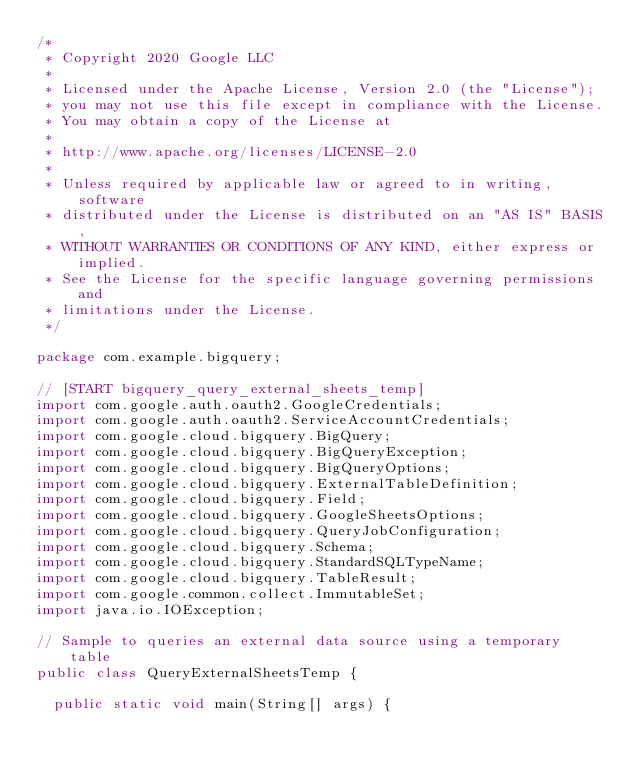<code> <loc_0><loc_0><loc_500><loc_500><_Java_>/*
 * Copyright 2020 Google LLC
 *
 * Licensed under the Apache License, Version 2.0 (the "License");
 * you may not use this file except in compliance with the License.
 * You may obtain a copy of the License at
 *
 * http://www.apache.org/licenses/LICENSE-2.0
 *
 * Unless required by applicable law or agreed to in writing, software
 * distributed under the License is distributed on an "AS IS" BASIS,
 * WITHOUT WARRANTIES OR CONDITIONS OF ANY KIND, either express or implied.
 * See the License for the specific language governing permissions and
 * limitations under the License.
 */

package com.example.bigquery;

// [START bigquery_query_external_sheets_temp]
import com.google.auth.oauth2.GoogleCredentials;
import com.google.auth.oauth2.ServiceAccountCredentials;
import com.google.cloud.bigquery.BigQuery;
import com.google.cloud.bigquery.BigQueryException;
import com.google.cloud.bigquery.BigQueryOptions;
import com.google.cloud.bigquery.ExternalTableDefinition;
import com.google.cloud.bigquery.Field;
import com.google.cloud.bigquery.GoogleSheetsOptions;
import com.google.cloud.bigquery.QueryJobConfiguration;
import com.google.cloud.bigquery.Schema;
import com.google.cloud.bigquery.StandardSQLTypeName;
import com.google.cloud.bigquery.TableResult;
import com.google.common.collect.ImmutableSet;
import java.io.IOException;

// Sample to queries an external data source using a temporary table
public class QueryExternalSheetsTemp {

  public static void main(String[] args) {</code> 